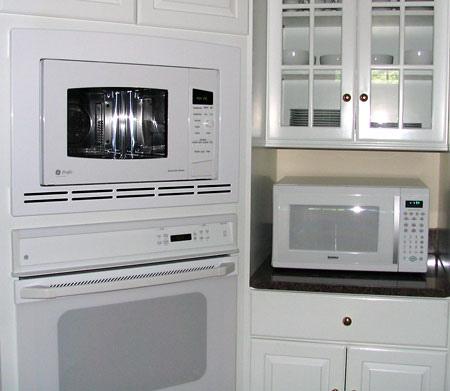What metal are the appliances made of?
Short answer required. Aluminum. How many bowls are in the cabinet?
Answer briefly. 4. What color is the microwave?
Answer briefly. White. Why can the plates and bowls in the cabinet be seen?
Be succinct. Glass cabinet. 